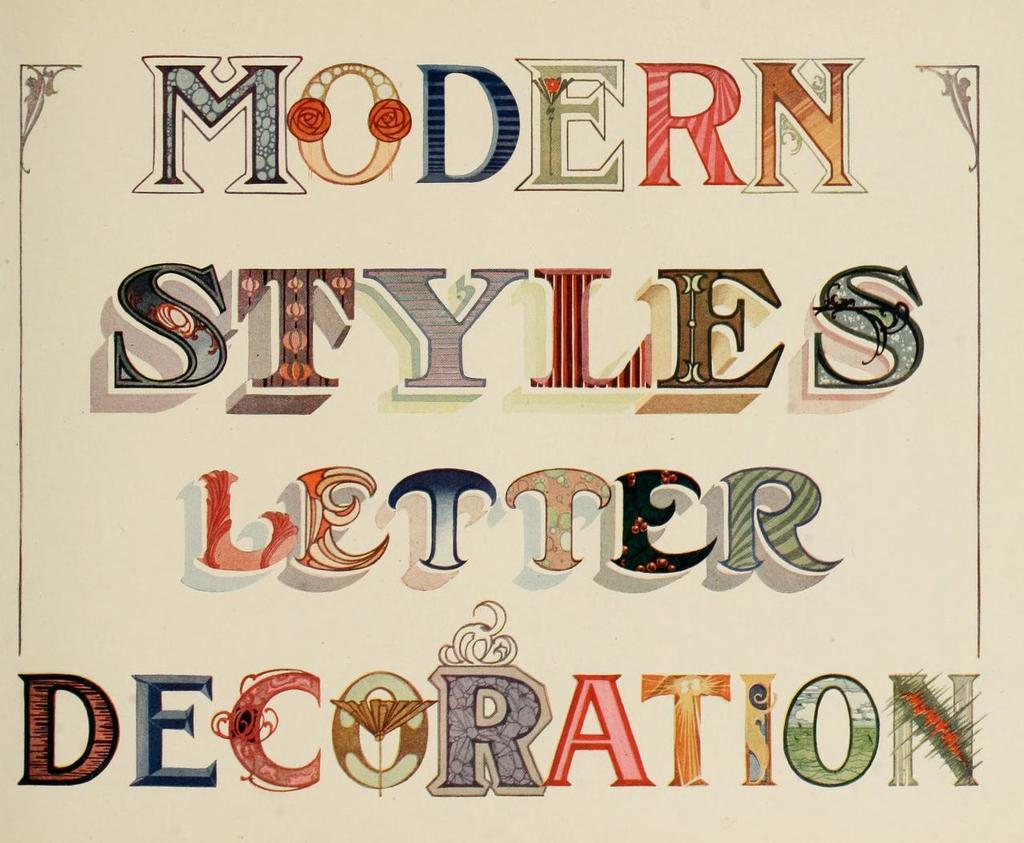How would you summarize this image in a sentence or two? In the image in the center, we can see one paper and we can see something written on it. 